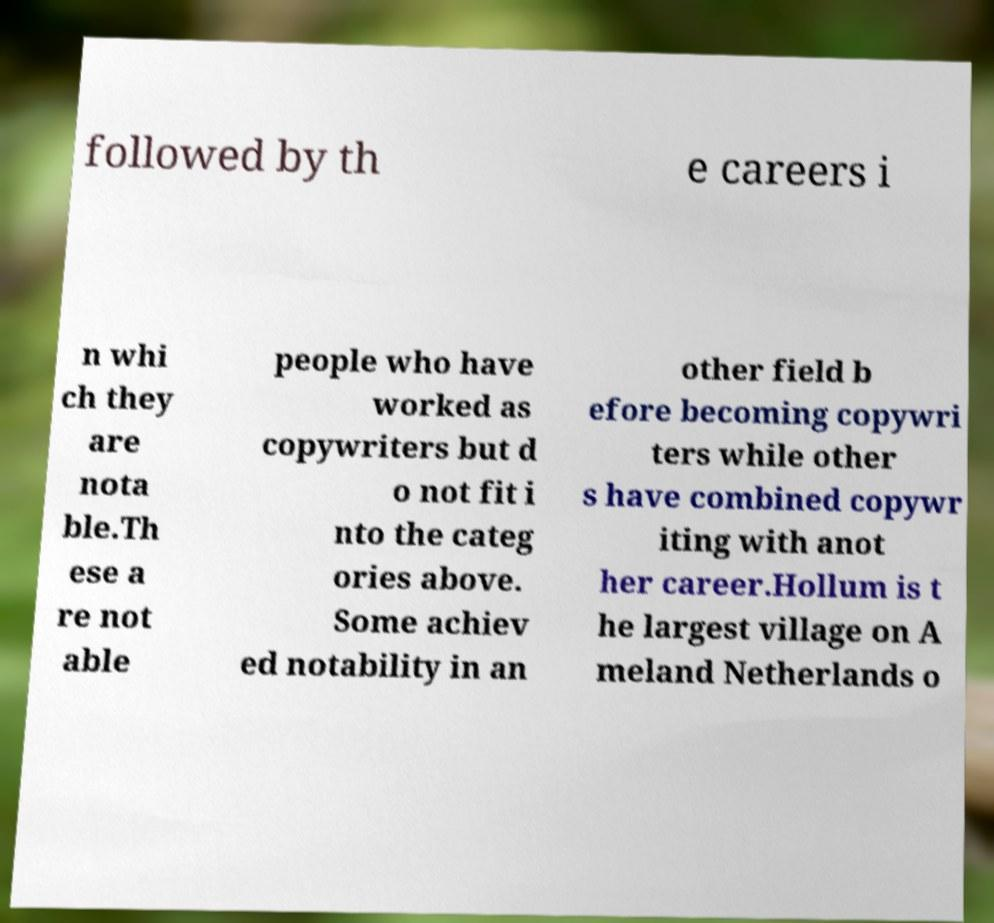For documentation purposes, I need the text within this image transcribed. Could you provide that? followed by th e careers i n whi ch they are nota ble.Th ese a re not able people who have worked as copywriters but d o not fit i nto the categ ories above. Some achiev ed notability in an other field b efore becoming copywri ters while other s have combined copywr iting with anot her career.Hollum is t he largest village on A meland Netherlands o 